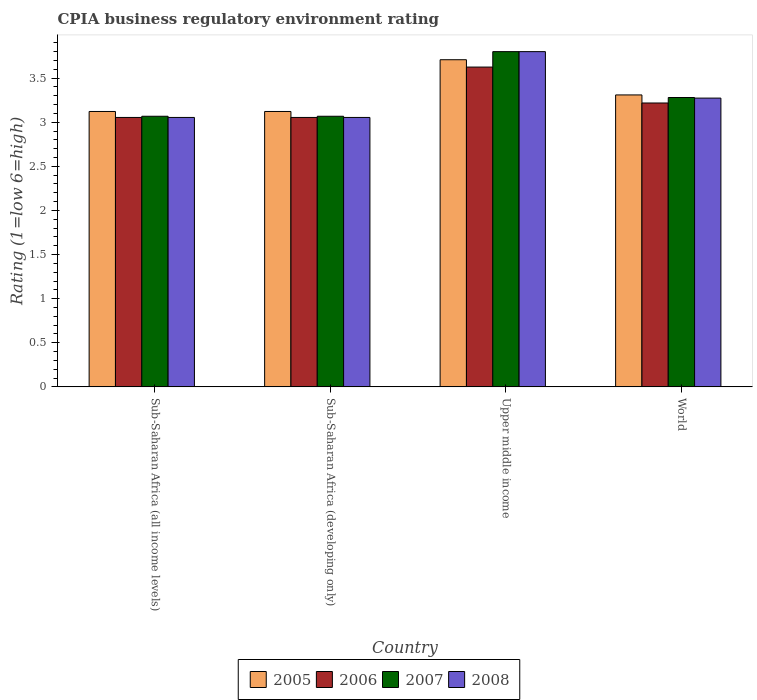How many different coloured bars are there?
Your response must be concise. 4. How many groups of bars are there?
Give a very brief answer. 4. Are the number of bars on each tick of the X-axis equal?
Give a very brief answer. Yes. How many bars are there on the 3rd tick from the left?
Ensure brevity in your answer.  4. How many bars are there on the 1st tick from the right?
Ensure brevity in your answer.  4. What is the label of the 4th group of bars from the left?
Ensure brevity in your answer.  World. What is the CPIA rating in 2006 in Sub-Saharan Africa (all income levels)?
Offer a very short reply. 3.05. Across all countries, what is the maximum CPIA rating in 2008?
Give a very brief answer. 3.8. Across all countries, what is the minimum CPIA rating in 2005?
Your response must be concise. 3.12. In which country was the CPIA rating in 2005 maximum?
Provide a succinct answer. Upper middle income. In which country was the CPIA rating in 2008 minimum?
Provide a short and direct response. Sub-Saharan Africa (all income levels). What is the total CPIA rating in 2007 in the graph?
Offer a terse response. 13.22. What is the difference between the CPIA rating in 2006 in Sub-Saharan Africa (all income levels) and that in Sub-Saharan Africa (developing only)?
Provide a short and direct response. 0. What is the difference between the CPIA rating in 2008 in Upper middle income and the CPIA rating in 2006 in Sub-Saharan Africa (developing only)?
Provide a succinct answer. 0.75. What is the average CPIA rating in 2008 per country?
Your answer should be compact. 3.3. What is the difference between the CPIA rating of/in 2005 and CPIA rating of/in 2008 in Upper middle income?
Your response must be concise. -0.09. In how many countries, is the CPIA rating in 2007 greater than 1.2?
Make the answer very short. 4. What is the ratio of the CPIA rating in 2008 in Sub-Saharan Africa (all income levels) to that in World?
Ensure brevity in your answer.  0.93. Is the CPIA rating in 2007 in Sub-Saharan Africa (developing only) less than that in World?
Your answer should be compact. Yes. What is the difference between the highest and the second highest CPIA rating in 2007?
Provide a succinct answer. -0.52. What is the difference between the highest and the lowest CPIA rating in 2005?
Your answer should be compact. 0.59. Is the sum of the CPIA rating in 2007 in Sub-Saharan Africa (developing only) and Upper middle income greater than the maximum CPIA rating in 2006 across all countries?
Your answer should be compact. Yes. What does the 3rd bar from the left in Upper middle income represents?
Make the answer very short. 2007. What does the 4th bar from the right in Sub-Saharan Africa (developing only) represents?
Your answer should be compact. 2005. Is it the case that in every country, the sum of the CPIA rating in 2006 and CPIA rating in 2005 is greater than the CPIA rating in 2008?
Offer a very short reply. Yes. How many countries are there in the graph?
Provide a short and direct response. 4. Does the graph contain grids?
Provide a succinct answer. No. Where does the legend appear in the graph?
Offer a terse response. Bottom center. How are the legend labels stacked?
Your answer should be compact. Horizontal. What is the title of the graph?
Your answer should be very brief. CPIA business regulatory environment rating. Does "1978" appear as one of the legend labels in the graph?
Provide a succinct answer. No. What is the label or title of the X-axis?
Ensure brevity in your answer.  Country. What is the Rating (1=low 6=high) of 2005 in Sub-Saharan Africa (all income levels)?
Provide a succinct answer. 3.12. What is the Rating (1=low 6=high) of 2006 in Sub-Saharan Africa (all income levels)?
Your answer should be compact. 3.05. What is the Rating (1=low 6=high) of 2007 in Sub-Saharan Africa (all income levels)?
Your answer should be compact. 3.07. What is the Rating (1=low 6=high) in 2008 in Sub-Saharan Africa (all income levels)?
Offer a terse response. 3.05. What is the Rating (1=low 6=high) of 2005 in Sub-Saharan Africa (developing only)?
Make the answer very short. 3.12. What is the Rating (1=low 6=high) in 2006 in Sub-Saharan Africa (developing only)?
Offer a very short reply. 3.05. What is the Rating (1=low 6=high) in 2007 in Sub-Saharan Africa (developing only)?
Keep it short and to the point. 3.07. What is the Rating (1=low 6=high) in 2008 in Sub-Saharan Africa (developing only)?
Your answer should be very brief. 3.05. What is the Rating (1=low 6=high) of 2005 in Upper middle income?
Offer a terse response. 3.71. What is the Rating (1=low 6=high) in 2006 in Upper middle income?
Keep it short and to the point. 3.62. What is the Rating (1=low 6=high) in 2007 in Upper middle income?
Your response must be concise. 3.8. What is the Rating (1=low 6=high) of 2005 in World?
Provide a succinct answer. 3.31. What is the Rating (1=low 6=high) of 2006 in World?
Keep it short and to the point. 3.22. What is the Rating (1=low 6=high) in 2007 in World?
Keep it short and to the point. 3.28. What is the Rating (1=low 6=high) in 2008 in World?
Provide a succinct answer. 3.27. Across all countries, what is the maximum Rating (1=low 6=high) of 2005?
Your answer should be very brief. 3.71. Across all countries, what is the maximum Rating (1=low 6=high) of 2006?
Keep it short and to the point. 3.62. Across all countries, what is the maximum Rating (1=low 6=high) in 2007?
Provide a succinct answer. 3.8. Across all countries, what is the minimum Rating (1=low 6=high) in 2005?
Ensure brevity in your answer.  3.12. Across all countries, what is the minimum Rating (1=low 6=high) of 2006?
Keep it short and to the point. 3.05. Across all countries, what is the minimum Rating (1=low 6=high) of 2007?
Provide a succinct answer. 3.07. Across all countries, what is the minimum Rating (1=low 6=high) of 2008?
Offer a very short reply. 3.05. What is the total Rating (1=low 6=high) of 2005 in the graph?
Keep it short and to the point. 13.26. What is the total Rating (1=low 6=high) in 2006 in the graph?
Ensure brevity in your answer.  12.95. What is the total Rating (1=low 6=high) of 2007 in the graph?
Your answer should be very brief. 13.22. What is the total Rating (1=low 6=high) in 2008 in the graph?
Ensure brevity in your answer.  13.18. What is the difference between the Rating (1=low 6=high) in 2005 in Sub-Saharan Africa (all income levels) and that in Sub-Saharan Africa (developing only)?
Keep it short and to the point. 0. What is the difference between the Rating (1=low 6=high) in 2006 in Sub-Saharan Africa (all income levels) and that in Sub-Saharan Africa (developing only)?
Your answer should be compact. 0. What is the difference between the Rating (1=low 6=high) of 2007 in Sub-Saharan Africa (all income levels) and that in Sub-Saharan Africa (developing only)?
Make the answer very short. 0. What is the difference between the Rating (1=low 6=high) of 2005 in Sub-Saharan Africa (all income levels) and that in Upper middle income?
Keep it short and to the point. -0.59. What is the difference between the Rating (1=low 6=high) of 2006 in Sub-Saharan Africa (all income levels) and that in Upper middle income?
Make the answer very short. -0.57. What is the difference between the Rating (1=low 6=high) of 2007 in Sub-Saharan Africa (all income levels) and that in Upper middle income?
Provide a short and direct response. -0.73. What is the difference between the Rating (1=low 6=high) in 2008 in Sub-Saharan Africa (all income levels) and that in Upper middle income?
Give a very brief answer. -0.75. What is the difference between the Rating (1=low 6=high) in 2005 in Sub-Saharan Africa (all income levels) and that in World?
Keep it short and to the point. -0.19. What is the difference between the Rating (1=low 6=high) in 2006 in Sub-Saharan Africa (all income levels) and that in World?
Make the answer very short. -0.16. What is the difference between the Rating (1=low 6=high) of 2007 in Sub-Saharan Africa (all income levels) and that in World?
Offer a terse response. -0.21. What is the difference between the Rating (1=low 6=high) in 2008 in Sub-Saharan Africa (all income levels) and that in World?
Your response must be concise. -0.22. What is the difference between the Rating (1=low 6=high) of 2005 in Sub-Saharan Africa (developing only) and that in Upper middle income?
Offer a terse response. -0.59. What is the difference between the Rating (1=low 6=high) of 2006 in Sub-Saharan Africa (developing only) and that in Upper middle income?
Make the answer very short. -0.57. What is the difference between the Rating (1=low 6=high) in 2007 in Sub-Saharan Africa (developing only) and that in Upper middle income?
Offer a terse response. -0.73. What is the difference between the Rating (1=low 6=high) of 2008 in Sub-Saharan Africa (developing only) and that in Upper middle income?
Provide a short and direct response. -0.75. What is the difference between the Rating (1=low 6=high) of 2005 in Sub-Saharan Africa (developing only) and that in World?
Your answer should be compact. -0.19. What is the difference between the Rating (1=low 6=high) in 2006 in Sub-Saharan Africa (developing only) and that in World?
Your answer should be very brief. -0.16. What is the difference between the Rating (1=low 6=high) in 2007 in Sub-Saharan Africa (developing only) and that in World?
Your answer should be compact. -0.21. What is the difference between the Rating (1=low 6=high) of 2008 in Sub-Saharan Africa (developing only) and that in World?
Offer a very short reply. -0.22. What is the difference between the Rating (1=low 6=high) in 2005 in Upper middle income and that in World?
Provide a succinct answer. 0.4. What is the difference between the Rating (1=low 6=high) in 2006 in Upper middle income and that in World?
Your response must be concise. 0.41. What is the difference between the Rating (1=low 6=high) in 2007 in Upper middle income and that in World?
Your response must be concise. 0.52. What is the difference between the Rating (1=low 6=high) in 2008 in Upper middle income and that in World?
Your answer should be very brief. 0.53. What is the difference between the Rating (1=low 6=high) of 2005 in Sub-Saharan Africa (all income levels) and the Rating (1=low 6=high) of 2006 in Sub-Saharan Africa (developing only)?
Keep it short and to the point. 0.07. What is the difference between the Rating (1=low 6=high) of 2005 in Sub-Saharan Africa (all income levels) and the Rating (1=low 6=high) of 2007 in Sub-Saharan Africa (developing only)?
Your answer should be compact. 0.05. What is the difference between the Rating (1=low 6=high) of 2005 in Sub-Saharan Africa (all income levels) and the Rating (1=low 6=high) of 2008 in Sub-Saharan Africa (developing only)?
Your response must be concise. 0.07. What is the difference between the Rating (1=low 6=high) of 2006 in Sub-Saharan Africa (all income levels) and the Rating (1=low 6=high) of 2007 in Sub-Saharan Africa (developing only)?
Your answer should be very brief. -0.01. What is the difference between the Rating (1=low 6=high) of 2006 in Sub-Saharan Africa (all income levels) and the Rating (1=low 6=high) of 2008 in Sub-Saharan Africa (developing only)?
Offer a terse response. 0. What is the difference between the Rating (1=low 6=high) in 2007 in Sub-Saharan Africa (all income levels) and the Rating (1=low 6=high) in 2008 in Sub-Saharan Africa (developing only)?
Your answer should be compact. 0.01. What is the difference between the Rating (1=low 6=high) in 2005 in Sub-Saharan Africa (all income levels) and the Rating (1=low 6=high) in 2006 in Upper middle income?
Provide a short and direct response. -0.5. What is the difference between the Rating (1=low 6=high) of 2005 in Sub-Saharan Africa (all income levels) and the Rating (1=low 6=high) of 2007 in Upper middle income?
Ensure brevity in your answer.  -0.68. What is the difference between the Rating (1=low 6=high) of 2005 in Sub-Saharan Africa (all income levels) and the Rating (1=low 6=high) of 2008 in Upper middle income?
Keep it short and to the point. -0.68. What is the difference between the Rating (1=low 6=high) in 2006 in Sub-Saharan Africa (all income levels) and the Rating (1=low 6=high) in 2007 in Upper middle income?
Give a very brief answer. -0.75. What is the difference between the Rating (1=low 6=high) in 2006 in Sub-Saharan Africa (all income levels) and the Rating (1=low 6=high) in 2008 in Upper middle income?
Give a very brief answer. -0.75. What is the difference between the Rating (1=low 6=high) in 2007 in Sub-Saharan Africa (all income levels) and the Rating (1=low 6=high) in 2008 in Upper middle income?
Your answer should be compact. -0.73. What is the difference between the Rating (1=low 6=high) of 2005 in Sub-Saharan Africa (all income levels) and the Rating (1=low 6=high) of 2006 in World?
Give a very brief answer. -0.1. What is the difference between the Rating (1=low 6=high) of 2005 in Sub-Saharan Africa (all income levels) and the Rating (1=low 6=high) of 2007 in World?
Your answer should be very brief. -0.16. What is the difference between the Rating (1=low 6=high) in 2005 in Sub-Saharan Africa (all income levels) and the Rating (1=low 6=high) in 2008 in World?
Your response must be concise. -0.15. What is the difference between the Rating (1=low 6=high) in 2006 in Sub-Saharan Africa (all income levels) and the Rating (1=low 6=high) in 2007 in World?
Provide a succinct answer. -0.23. What is the difference between the Rating (1=low 6=high) of 2006 in Sub-Saharan Africa (all income levels) and the Rating (1=low 6=high) of 2008 in World?
Your answer should be very brief. -0.22. What is the difference between the Rating (1=low 6=high) in 2007 in Sub-Saharan Africa (all income levels) and the Rating (1=low 6=high) in 2008 in World?
Ensure brevity in your answer.  -0.21. What is the difference between the Rating (1=low 6=high) of 2005 in Sub-Saharan Africa (developing only) and the Rating (1=low 6=high) of 2006 in Upper middle income?
Provide a short and direct response. -0.5. What is the difference between the Rating (1=low 6=high) of 2005 in Sub-Saharan Africa (developing only) and the Rating (1=low 6=high) of 2007 in Upper middle income?
Your answer should be compact. -0.68. What is the difference between the Rating (1=low 6=high) in 2005 in Sub-Saharan Africa (developing only) and the Rating (1=low 6=high) in 2008 in Upper middle income?
Offer a very short reply. -0.68. What is the difference between the Rating (1=low 6=high) in 2006 in Sub-Saharan Africa (developing only) and the Rating (1=low 6=high) in 2007 in Upper middle income?
Provide a short and direct response. -0.75. What is the difference between the Rating (1=low 6=high) of 2006 in Sub-Saharan Africa (developing only) and the Rating (1=low 6=high) of 2008 in Upper middle income?
Give a very brief answer. -0.75. What is the difference between the Rating (1=low 6=high) of 2007 in Sub-Saharan Africa (developing only) and the Rating (1=low 6=high) of 2008 in Upper middle income?
Provide a short and direct response. -0.73. What is the difference between the Rating (1=low 6=high) of 2005 in Sub-Saharan Africa (developing only) and the Rating (1=low 6=high) of 2006 in World?
Give a very brief answer. -0.1. What is the difference between the Rating (1=low 6=high) of 2005 in Sub-Saharan Africa (developing only) and the Rating (1=low 6=high) of 2007 in World?
Offer a very short reply. -0.16. What is the difference between the Rating (1=low 6=high) in 2005 in Sub-Saharan Africa (developing only) and the Rating (1=low 6=high) in 2008 in World?
Your response must be concise. -0.15. What is the difference between the Rating (1=low 6=high) of 2006 in Sub-Saharan Africa (developing only) and the Rating (1=low 6=high) of 2007 in World?
Make the answer very short. -0.23. What is the difference between the Rating (1=low 6=high) in 2006 in Sub-Saharan Africa (developing only) and the Rating (1=low 6=high) in 2008 in World?
Provide a short and direct response. -0.22. What is the difference between the Rating (1=low 6=high) of 2007 in Sub-Saharan Africa (developing only) and the Rating (1=low 6=high) of 2008 in World?
Your answer should be compact. -0.21. What is the difference between the Rating (1=low 6=high) in 2005 in Upper middle income and the Rating (1=low 6=high) in 2006 in World?
Ensure brevity in your answer.  0.49. What is the difference between the Rating (1=low 6=high) of 2005 in Upper middle income and the Rating (1=low 6=high) of 2007 in World?
Provide a short and direct response. 0.43. What is the difference between the Rating (1=low 6=high) of 2005 in Upper middle income and the Rating (1=low 6=high) of 2008 in World?
Your answer should be compact. 0.43. What is the difference between the Rating (1=low 6=high) in 2006 in Upper middle income and the Rating (1=low 6=high) in 2007 in World?
Your response must be concise. 0.34. What is the difference between the Rating (1=low 6=high) of 2006 in Upper middle income and the Rating (1=low 6=high) of 2008 in World?
Offer a very short reply. 0.35. What is the difference between the Rating (1=low 6=high) in 2007 in Upper middle income and the Rating (1=low 6=high) in 2008 in World?
Make the answer very short. 0.53. What is the average Rating (1=low 6=high) in 2005 per country?
Provide a succinct answer. 3.32. What is the average Rating (1=low 6=high) in 2006 per country?
Offer a terse response. 3.24. What is the average Rating (1=low 6=high) of 2007 per country?
Your response must be concise. 3.3. What is the average Rating (1=low 6=high) in 2008 per country?
Make the answer very short. 3.3. What is the difference between the Rating (1=low 6=high) of 2005 and Rating (1=low 6=high) of 2006 in Sub-Saharan Africa (all income levels)?
Provide a succinct answer. 0.07. What is the difference between the Rating (1=low 6=high) in 2005 and Rating (1=low 6=high) in 2007 in Sub-Saharan Africa (all income levels)?
Offer a terse response. 0.05. What is the difference between the Rating (1=low 6=high) of 2005 and Rating (1=low 6=high) of 2008 in Sub-Saharan Africa (all income levels)?
Keep it short and to the point. 0.07. What is the difference between the Rating (1=low 6=high) in 2006 and Rating (1=low 6=high) in 2007 in Sub-Saharan Africa (all income levels)?
Make the answer very short. -0.01. What is the difference between the Rating (1=low 6=high) of 2006 and Rating (1=low 6=high) of 2008 in Sub-Saharan Africa (all income levels)?
Provide a succinct answer. 0. What is the difference between the Rating (1=low 6=high) of 2007 and Rating (1=low 6=high) of 2008 in Sub-Saharan Africa (all income levels)?
Your answer should be very brief. 0.01. What is the difference between the Rating (1=low 6=high) in 2005 and Rating (1=low 6=high) in 2006 in Sub-Saharan Africa (developing only)?
Your response must be concise. 0.07. What is the difference between the Rating (1=low 6=high) in 2005 and Rating (1=low 6=high) in 2007 in Sub-Saharan Africa (developing only)?
Offer a terse response. 0.05. What is the difference between the Rating (1=low 6=high) of 2005 and Rating (1=low 6=high) of 2008 in Sub-Saharan Africa (developing only)?
Your answer should be very brief. 0.07. What is the difference between the Rating (1=low 6=high) in 2006 and Rating (1=low 6=high) in 2007 in Sub-Saharan Africa (developing only)?
Give a very brief answer. -0.01. What is the difference between the Rating (1=low 6=high) in 2007 and Rating (1=low 6=high) in 2008 in Sub-Saharan Africa (developing only)?
Keep it short and to the point. 0.01. What is the difference between the Rating (1=low 6=high) of 2005 and Rating (1=low 6=high) of 2006 in Upper middle income?
Your answer should be compact. 0.08. What is the difference between the Rating (1=low 6=high) in 2005 and Rating (1=low 6=high) in 2007 in Upper middle income?
Your response must be concise. -0.09. What is the difference between the Rating (1=low 6=high) in 2005 and Rating (1=low 6=high) in 2008 in Upper middle income?
Your answer should be very brief. -0.09. What is the difference between the Rating (1=low 6=high) in 2006 and Rating (1=low 6=high) in 2007 in Upper middle income?
Offer a terse response. -0.17. What is the difference between the Rating (1=low 6=high) of 2006 and Rating (1=low 6=high) of 2008 in Upper middle income?
Make the answer very short. -0.17. What is the difference between the Rating (1=low 6=high) in 2007 and Rating (1=low 6=high) in 2008 in Upper middle income?
Ensure brevity in your answer.  0. What is the difference between the Rating (1=low 6=high) of 2005 and Rating (1=low 6=high) of 2006 in World?
Offer a very short reply. 0.09. What is the difference between the Rating (1=low 6=high) in 2005 and Rating (1=low 6=high) in 2007 in World?
Your answer should be very brief. 0.03. What is the difference between the Rating (1=low 6=high) in 2005 and Rating (1=low 6=high) in 2008 in World?
Your answer should be compact. 0.04. What is the difference between the Rating (1=low 6=high) of 2006 and Rating (1=low 6=high) of 2007 in World?
Your answer should be compact. -0.06. What is the difference between the Rating (1=low 6=high) of 2006 and Rating (1=low 6=high) of 2008 in World?
Offer a very short reply. -0.06. What is the difference between the Rating (1=low 6=high) of 2007 and Rating (1=low 6=high) of 2008 in World?
Offer a very short reply. 0.01. What is the ratio of the Rating (1=low 6=high) of 2005 in Sub-Saharan Africa (all income levels) to that in Sub-Saharan Africa (developing only)?
Offer a terse response. 1. What is the ratio of the Rating (1=low 6=high) of 2006 in Sub-Saharan Africa (all income levels) to that in Sub-Saharan Africa (developing only)?
Ensure brevity in your answer.  1. What is the ratio of the Rating (1=low 6=high) of 2008 in Sub-Saharan Africa (all income levels) to that in Sub-Saharan Africa (developing only)?
Make the answer very short. 1. What is the ratio of the Rating (1=low 6=high) of 2005 in Sub-Saharan Africa (all income levels) to that in Upper middle income?
Provide a succinct answer. 0.84. What is the ratio of the Rating (1=low 6=high) in 2006 in Sub-Saharan Africa (all income levels) to that in Upper middle income?
Ensure brevity in your answer.  0.84. What is the ratio of the Rating (1=low 6=high) of 2007 in Sub-Saharan Africa (all income levels) to that in Upper middle income?
Provide a short and direct response. 0.81. What is the ratio of the Rating (1=low 6=high) in 2008 in Sub-Saharan Africa (all income levels) to that in Upper middle income?
Your answer should be very brief. 0.8. What is the ratio of the Rating (1=low 6=high) in 2005 in Sub-Saharan Africa (all income levels) to that in World?
Your response must be concise. 0.94. What is the ratio of the Rating (1=low 6=high) in 2006 in Sub-Saharan Africa (all income levels) to that in World?
Your answer should be compact. 0.95. What is the ratio of the Rating (1=low 6=high) of 2007 in Sub-Saharan Africa (all income levels) to that in World?
Offer a very short reply. 0.94. What is the ratio of the Rating (1=low 6=high) of 2008 in Sub-Saharan Africa (all income levels) to that in World?
Your answer should be compact. 0.93. What is the ratio of the Rating (1=low 6=high) of 2005 in Sub-Saharan Africa (developing only) to that in Upper middle income?
Provide a short and direct response. 0.84. What is the ratio of the Rating (1=low 6=high) in 2006 in Sub-Saharan Africa (developing only) to that in Upper middle income?
Offer a very short reply. 0.84. What is the ratio of the Rating (1=low 6=high) in 2007 in Sub-Saharan Africa (developing only) to that in Upper middle income?
Provide a succinct answer. 0.81. What is the ratio of the Rating (1=low 6=high) in 2008 in Sub-Saharan Africa (developing only) to that in Upper middle income?
Provide a short and direct response. 0.8. What is the ratio of the Rating (1=low 6=high) of 2005 in Sub-Saharan Africa (developing only) to that in World?
Your response must be concise. 0.94. What is the ratio of the Rating (1=low 6=high) of 2006 in Sub-Saharan Africa (developing only) to that in World?
Keep it short and to the point. 0.95. What is the ratio of the Rating (1=low 6=high) in 2007 in Sub-Saharan Africa (developing only) to that in World?
Provide a short and direct response. 0.94. What is the ratio of the Rating (1=low 6=high) of 2008 in Sub-Saharan Africa (developing only) to that in World?
Provide a succinct answer. 0.93. What is the ratio of the Rating (1=low 6=high) in 2005 in Upper middle income to that in World?
Give a very brief answer. 1.12. What is the ratio of the Rating (1=low 6=high) of 2006 in Upper middle income to that in World?
Make the answer very short. 1.13. What is the ratio of the Rating (1=low 6=high) in 2007 in Upper middle income to that in World?
Give a very brief answer. 1.16. What is the ratio of the Rating (1=low 6=high) of 2008 in Upper middle income to that in World?
Provide a short and direct response. 1.16. What is the difference between the highest and the second highest Rating (1=low 6=high) of 2005?
Provide a short and direct response. 0.4. What is the difference between the highest and the second highest Rating (1=low 6=high) of 2006?
Ensure brevity in your answer.  0.41. What is the difference between the highest and the second highest Rating (1=low 6=high) in 2007?
Give a very brief answer. 0.52. What is the difference between the highest and the second highest Rating (1=low 6=high) in 2008?
Give a very brief answer. 0.53. What is the difference between the highest and the lowest Rating (1=low 6=high) of 2005?
Offer a terse response. 0.59. What is the difference between the highest and the lowest Rating (1=low 6=high) of 2006?
Offer a very short reply. 0.57. What is the difference between the highest and the lowest Rating (1=low 6=high) in 2007?
Provide a succinct answer. 0.73. What is the difference between the highest and the lowest Rating (1=low 6=high) in 2008?
Provide a short and direct response. 0.75. 